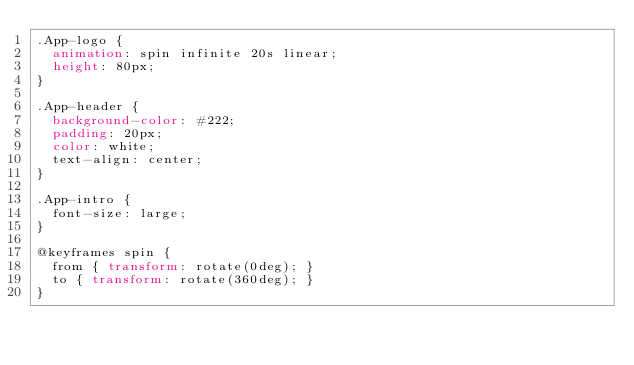<code> <loc_0><loc_0><loc_500><loc_500><_CSS_>.App-logo {
  animation: spin infinite 20s linear;
  height: 80px;
}

.App-header {
  background-color: #222;
  padding: 20px;
  color: white;
  text-align: center;
}

.App-intro {
  font-size: large;
}

@keyframes spin {
  from { transform: rotate(0deg); }
  to { transform: rotate(360deg); }
}
</code> 